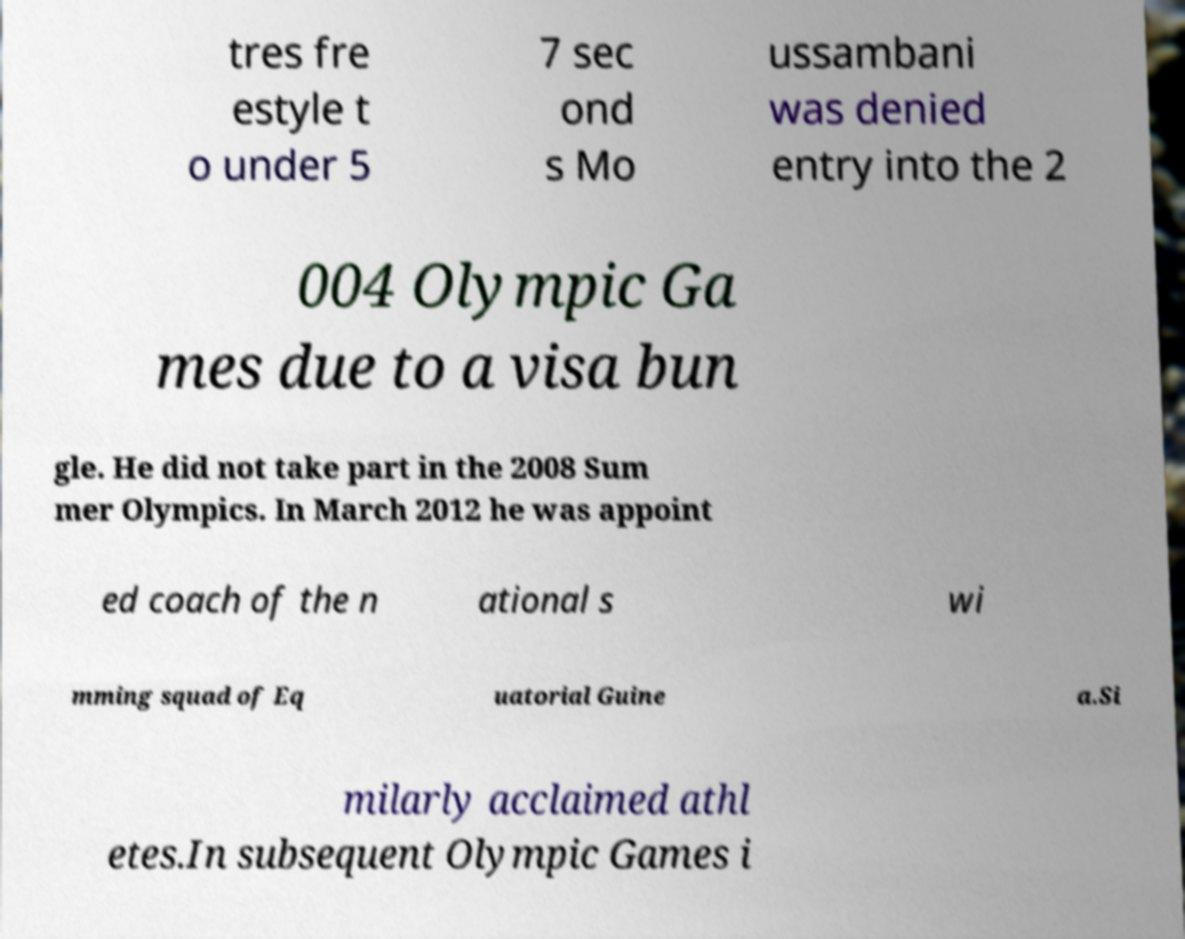Could you extract and type out the text from this image? tres fre estyle t o under 5 7 sec ond s Mo ussambani was denied entry into the 2 004 Olympic Ga mes due to a visa bun gle. He did not take part in the 2008 Sum mer Olympics. In March 2012 he was appoint ed coach of the n ational s wi mming squad of Eq uatorial Guine a.Si milarly acclaimed athl etes.In subsequent Olympic Games i 